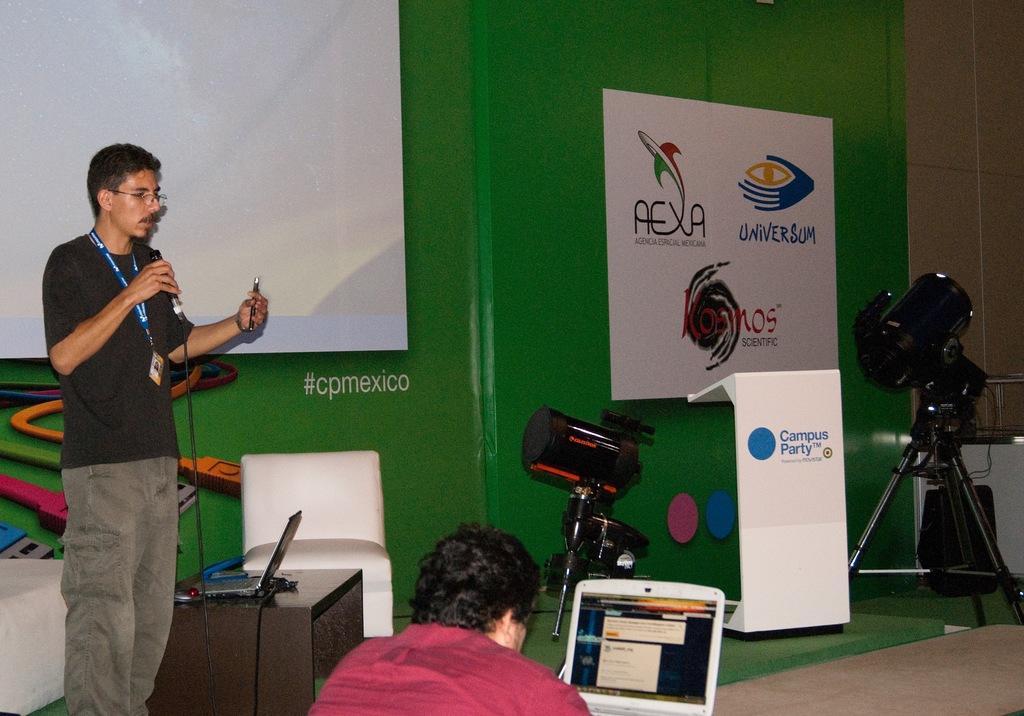Can you describe this image briefly? In this image we can see a man standing on the floor holding a mic and a pen. We can also see a table beside him containing some wires and a laptop, some chairs, flash lights with the stand and a wall with some text and pictures on it. On the bottom of the image we can see a person sitting beside a laptop. 